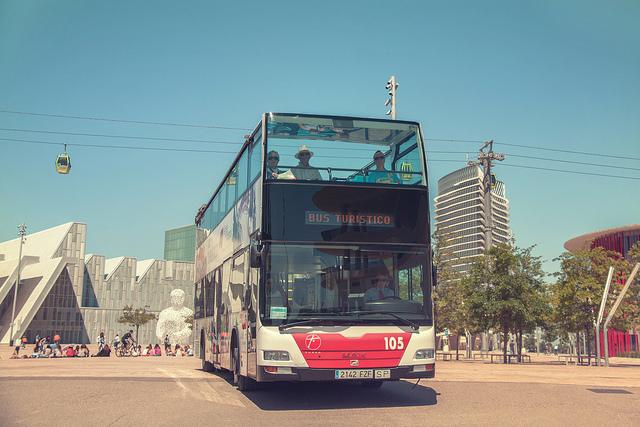What are the men on?
Concise answer only. Bus. Is it daylight?
Short answer required. Yes. Will the bus hit the power line?
Write a very short answer. No. Who works at Farmacia?
Short answer required. Farmers. Is it night time?
Give a very brief answer. No. Which bus route is the bus running?
Answer briefly. Turistico. How many levels does the bus have?
Give a very brief answer. 2. Who is on the side of the bus?
Give a very brief answer. Windows. Where are the red and white stripes?
Be succinct. Bus. What season does it appear to be?
Answer briefly. Summer. What color is this double Decker bus?
Write a very short answer. White. In what city is this scene from?
Answer briefly. Toronto. What s the middle number?
Concise answer only. 0. What is on top of the car?
Give a very brief answer. People. How many buses are in the picture?
Be succinct. 1. How many buses are there?
Be succinct. 1. Is it day time?
Concise answer only. Yes. Is a bus driving past?
Short answer required. Yes. Are there clouds?
Give a very brief answer. No. 